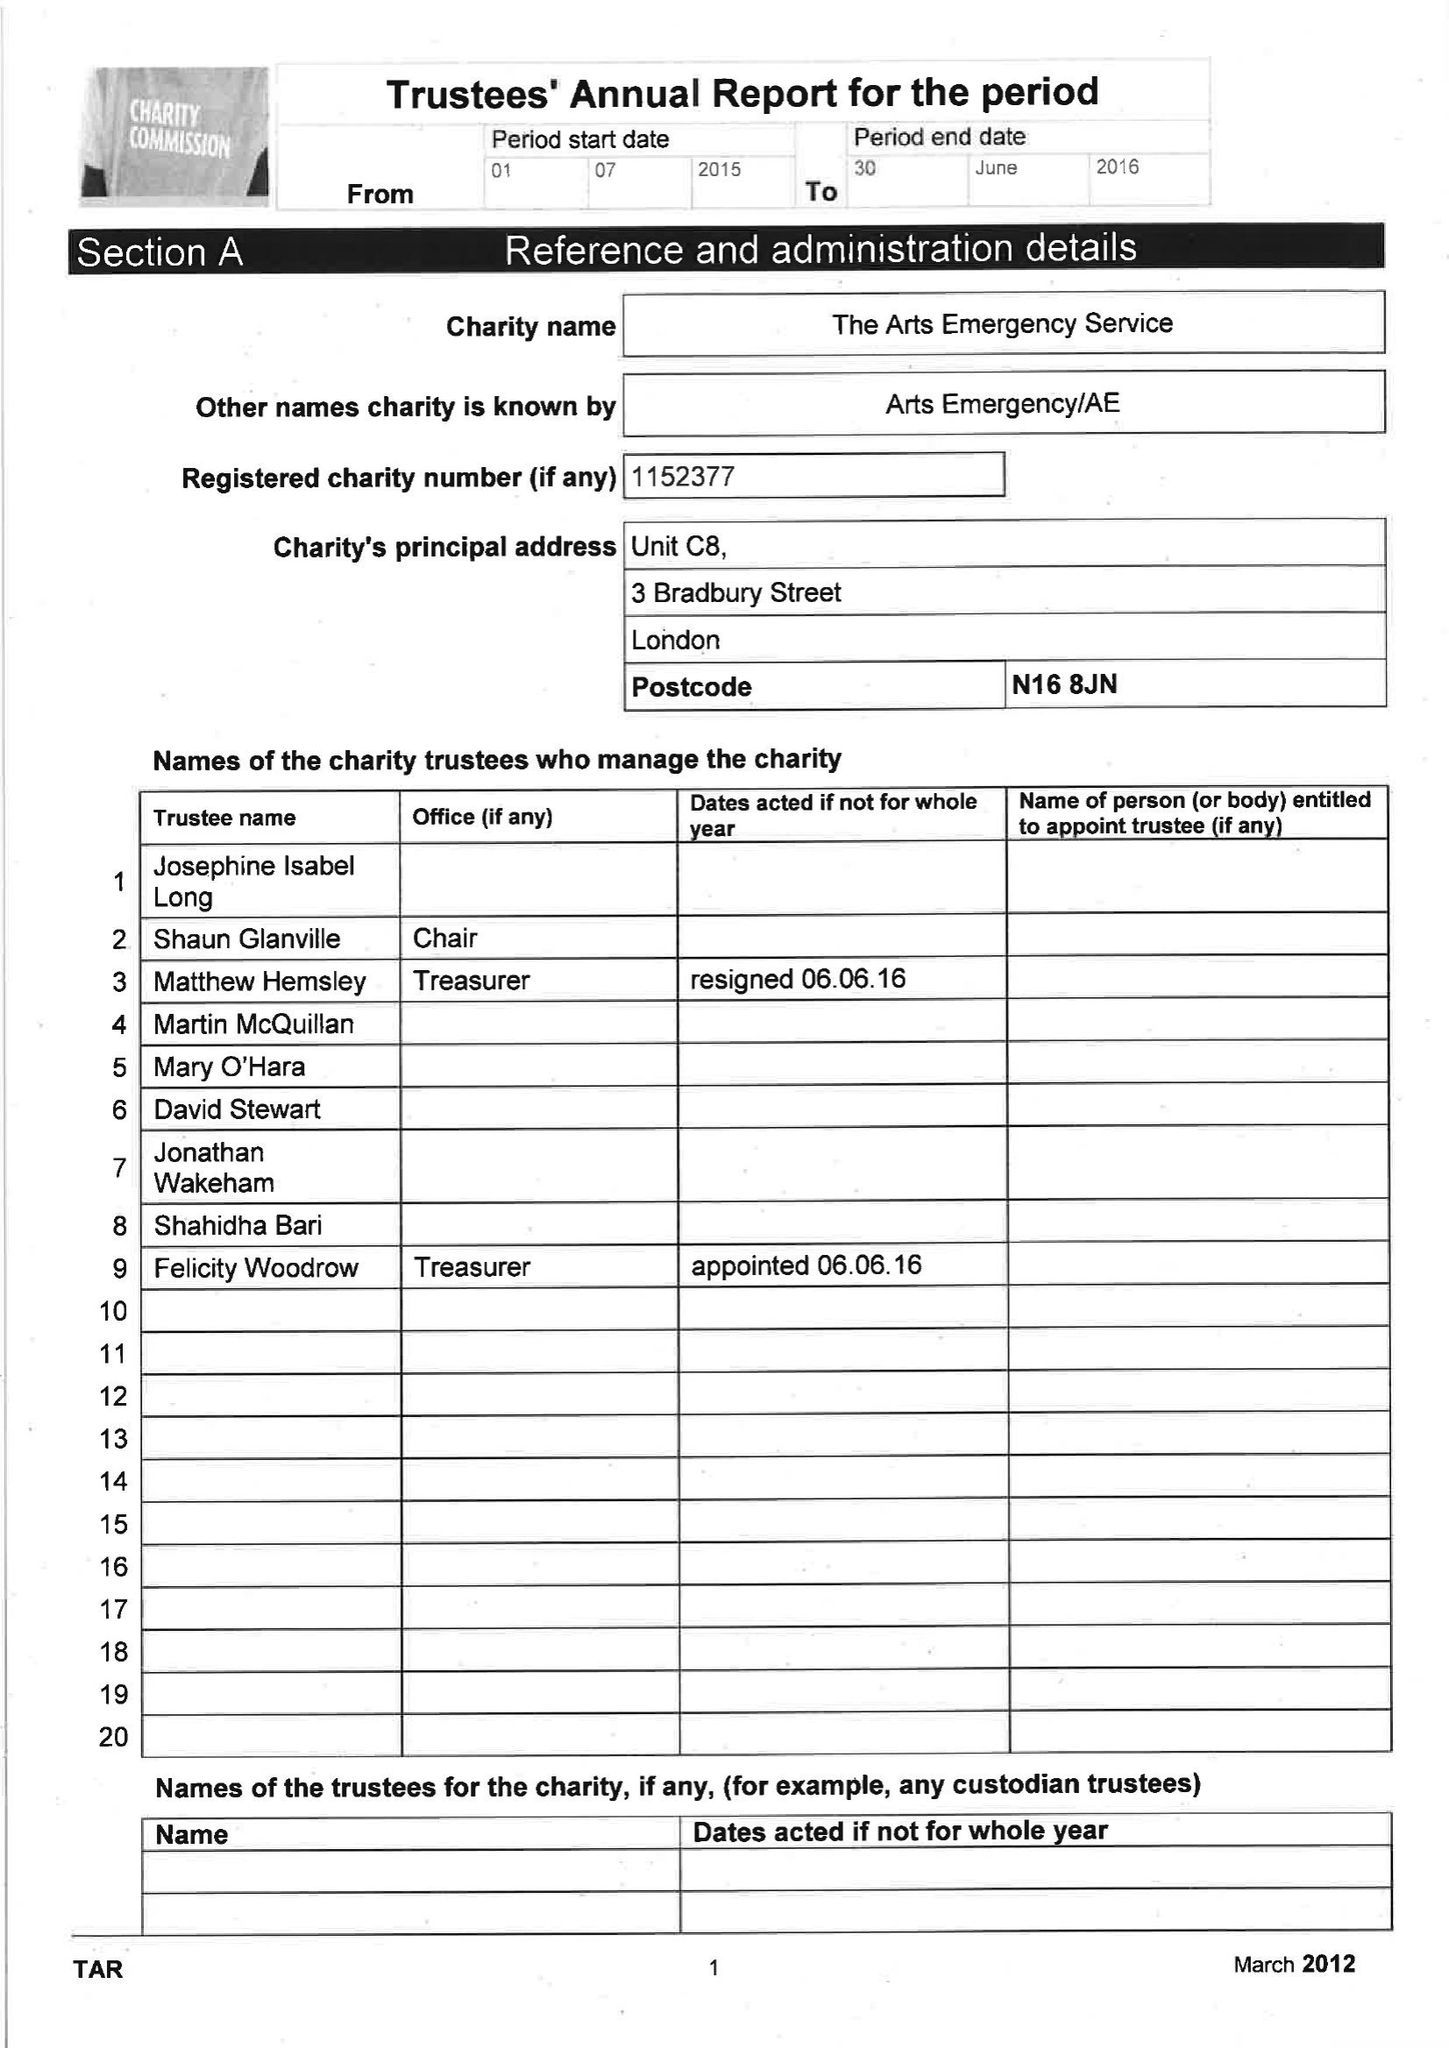What is the value for the report_date?
Answer the question using a single word or phrase. 2016-06-30 